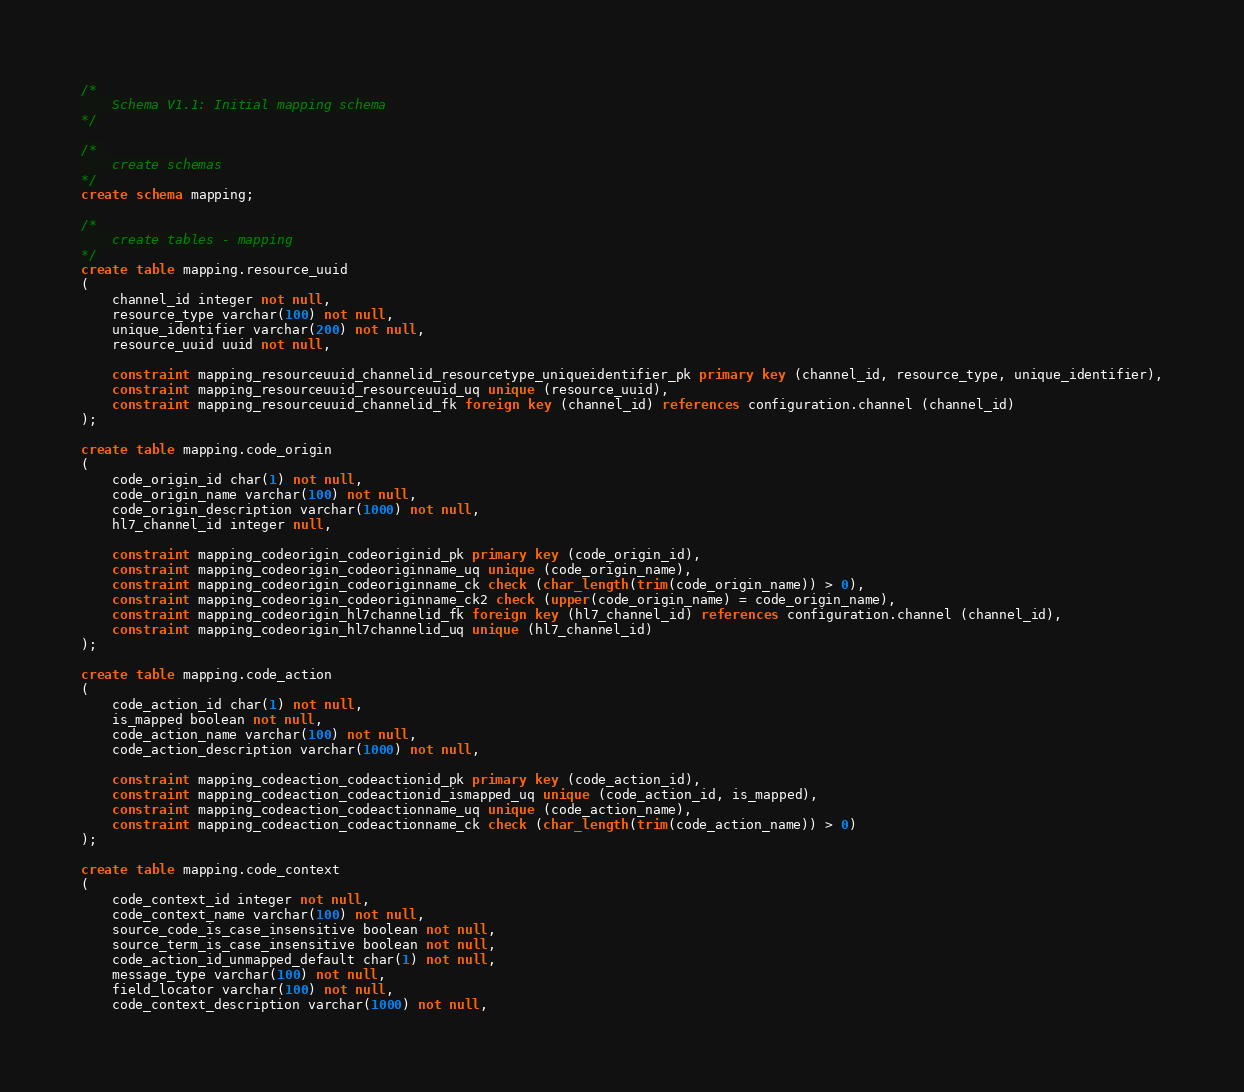Convert code to text. <code><loc_0><loc_0><loc_500><loc_500><_SQL_>/*
	Schema V1.1: Initial mapping schema
*/

/* 
	create schemas
*/
create schema mapping;

/*
	create tables - mapping
*/
create table mapping.resource_uuid
(
	channel_id integer not null,
	resource_type varchar(100) not null,
	unique_identifier varchar(200) not null,
	resource_uuid uuid not null,
	
	constraint mapping_resourceuuid_channelid_resourcetype_uniqueidentifier_pk primary key (channel_id, resource_type, unique_identifier),
	constraint mapping_resourceuuid_resourceuuid_uq unique (resource_uuid),
	constraint mapping_resourceuuid_channelid_fk foreign key (channel_id) references configuration.channel (channel_id)
);

create table mapping.code_origin
(
	code_origin_id char(1) not null,
	code_origin_name varchar(100) not null,
	code_origin_description varchar(1000) not null,
	hl7_channel_id integer null,
	
	constraint mapping_codeorigin_codeoriginid_pk primary key (code_origin_id),
	constraint mapping_codeorigin_codeoriginname_uq unique (code_origin_name),
	constraint mapping_codeorigin_codeoriginname_ck check (char_length(trim(code_origin_name)) > 0),
	constraint mapping_codeorigin_codeoriginname_ck2 check (upper(code_origin_name) = code_origin_name),
	constraint mapping_codeorigin_hl7channelid_fk foreign key (hl7_channel_id) references configuration.channel (channel_id),
	constraint mapping_codeorigin_hl7channelid_uq unique (hl7_channel_id)
);

create table mapping.code_action
(
	code_action_id char(1) not null,
	is_mapped boolean not null,
	code_action_name varchar(100) not null,
	code_action_description varchar(1000) not null,
	
	constraint mapping_codeaction_codeactionid_pk primary key (code_action_id),
	constraint mapping_codeaction_codeactionid_ismapped_uq unique (code_action_id, is_mapped),
	constraint mapping_codeaction_codeactionname_uq unique (code_action_name),
	constraint mapping_codeaction_codeactionname_ck check (char_length(trim(code_action_name)) > 0)
);

create table mapping.code_context
(
	code_context_id integer not null,
	code_context_name varchar(100) not null,
	source_code_is_case_insensitive boolean not null,
	source_term_is_case_insensitive boolean not null,
	code_action_id_unmapped_default char(1) not null,
	message_type varchar(100) not null,
	field_locator varchar(100) not null,
	code_context_description varchar(1000) not null,</code> 